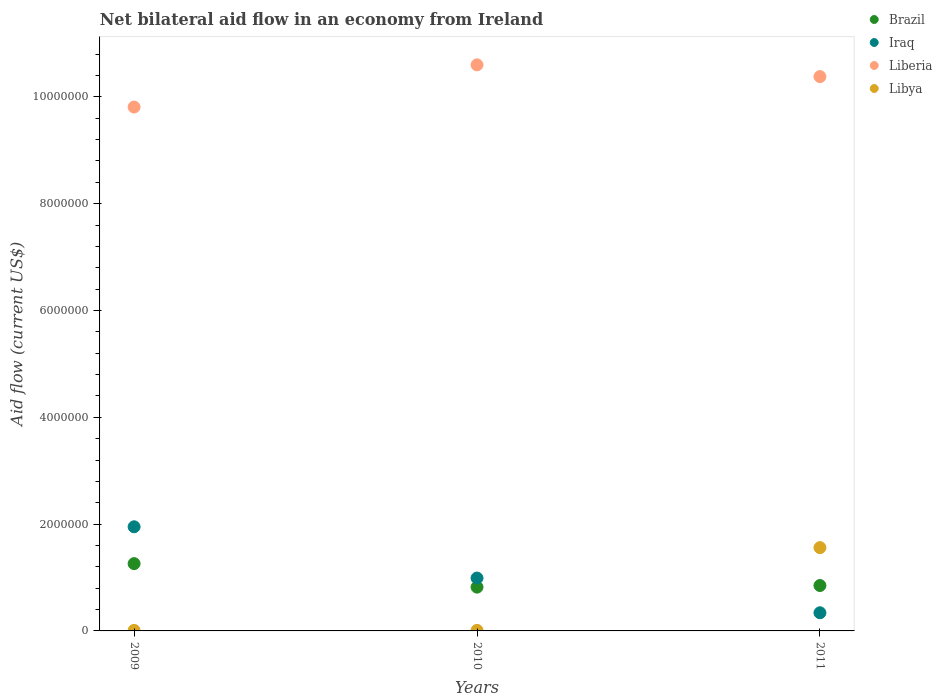How many different coloured dotlines are there?
Offer a very short reply. 4. What is the net bilateral aid flow in Iraq in 2009?
Your answer should be compact. 1.95e+06. Across all years, what is the maximum net bilateral aid flow in Liberia?
Offer a very short reply. 1.06e+07. Across all years, what is the minimum net bilateral aid flow in Brazil?
Your response must be concise. 8.20e+05. In which year was the net bilateral aid flow in Libya maximum?
Ensure brevity in your answer.  2011. In which year was the net bilateral aid flow in Liberia minimum?
Your answer should be compact. 2009. What is the total net bilateral aid flow in Liberia in the graph?
Ensure brevity in your answer.  3.08e+07. What is the difference between the net bilateral aid flow in Brazil in 2009 and that in 2011?
Give a very brief answer. 4.10e+05. What is the difference between the net bilateral aid flow in Liberia in 2011 and the net bilateral aid flow in Iraq in 2010?
Your response must be concise. 9.39e+06. What is the average net bilateral aid flow in Liberia per year?
Your answer should be compact. 1.03e+07. In the year 2010, what is the difference between the net bilateral aid flow in Liberia and net bilateral aid flow in Iraq?
Your answer should be very brief. 9.61e+06. What is the ratio of the net bilateral aid flow in Libya in 2009 to that in 2011?
Make the answer very short. 0.01. Is the net bilateral aid flow in Brazil in 2010 less than that in 2011?
Your answer should be very brief. Yes. What is the difference between the highest and the second highest net bilateral aid flow in Libya?
Ensure brevity in your answer.  1.55e+06. What is the difference between the highest and the lowest net bilateral aid flow in Libya?
Provide a succinct answer. 1.55e+06. In how many years, is the net bilateral aid flow in Iraq greater than the average net bilateral aid flow in Iraq taken over all years?
Offer a very short reply. 1. Is it the case that in every year, the sum of the net bilateral aid flow in Libya and net bilateral aid flow in Brazil  is greater than the sum of net bilateral aid flow in Liberia and net bilateral aid flow in Iraq?
Your answer should be compact. No. Does the net bilateral aid flow in Iraq monotonically increase over the years?
Ensure brevity in your answer.  No. Is the net bilateral aid flow in Libya strictly greater than the net bilateral aid flow in Iraq over the years?
Offer a very short reply. No. How many dotlines are there?
Offer a terse response. 4. How many years are there in the graph?
Make the answer very short. 3. Does the graph contain any zero values?
Give a very brief answer. No. Does the graph contain grids?
Give a very brief answer. No. Where does the legend appear in the graph?
Ensure brevity in your answer.  Top right. How many legend labels are there?
Make the answer very short. 4. What is the title of the graph?
Keep it short and to the point. Net bilateral aid flow in an economy from Ireland. Does "Gabon" appear as one of the legend labels in the graph?
Make the answer very short. No. What is the label or title of the Y-axis?
Your answer should be compact. Aid flow (current US$). What is the Aid flow (current US$) in Brazil in 2009?
Provide a succinct answer. 1.26e+06. What is the Aid flow (current US$) of Iraq in 2009?
Your answer should be compact. 1.95e+06. What is the Aid flow (current US$) in Liberia in 2009?
Provide a succinct answer. 9.81e+06. What is the Aid flow (current US$) of Brazil in 2010?
Your response must be concise. 8.20e+05. What is the Aid flow (current US$) of Iraq in 2010?
Offer a very short reply. 9.90e+05. What is the Aid flow (current US$) of Liberia in 2010?
Make the answer very short. 1.06e+07. What is the Aid flow (current US$) of Brazil in 2011?
Make the answer very short. 8.50e+05. What is the Aid flow (current US$) in Liberia in 2011?
Make the answer very short. 1.04e+07. What is the Aid flow (current US$) of Libya in 2011?
Your answer should be compact. 1.56e+06. Across all years, what is the maximum Aid flow (current US$) in Brazil?
Your answer should be very brief. 1.26e+06. Across all years, what is the maximum Aid flow (current US$) of Iraq?
Your response must be concise. 1.95e+06. Across all years, what is the maximum Aid flow (current US$) in Liberia?
Offer a very short reply. 1.06e+07. Across all years, what is the maximum Aid flow (current US$) of Libya?
Your answer should be very brief. 1.56e+06. Across all years, what is the minimum Aid flow (current US$) of Brazil?
Make the answer very short. 8.20e+05. Across all years, what is the minimum Aid flow (current US$) in Liberia?
Provide a short and direct response. 9.81e+06. What is the total Aid flow (current US$) of Brazil in the graph?
Provide a short and direct response. 2.93e+06. What is the total Aid flow (current US$) of Iraq in the graph?
Your answer should be very brief. 3.28e+06. What is the total Aid flow (current US$) in Liberia in the graph?
Ensure brevity in your answer.  3.08e+07. What is the total Aid flow (current US$) in Libya in the graph?
Offer a terse response. 1.58e+06. What is the difference between the Aid flow (current US$) in Brazil in 2009 and that in 2010?
Offer a terse response. 4.40e+05. What is the difference between the Aid flow (current US$) in Iraq in 2009 and that in 2010?
Your answer should be compact. 9.60e+05. What is the difference between the Aid flow (current US$) in Liberia in 2009 and that in 2010?
Provide a succinct answer. -7.90e+05. What is the difference between the Aid flow (current US$) in Brazil in 2009 and that in 2011?
Your response must be concise. 4.10e+05. What is the difference between the Aid flow (current US$) in Iraq in 2009 and that in 2011?
Keep it short and to the point. 1.61e+06. What is the difference between the Aid flow (current US$) of Liberia in 2009 and that in 2011?
Offer a very short reply. -5.70e+05. What is the difference between the Aid flow (current US$) of Libya in 2009 and that in 2011?
Your response must be concise. -1.55e+06. What is the difference between the Aid flow (current US$) in Brazil in 2010 and that in 2011?
Offer a terse response. -3.00e+04. What is the difference between the Aid flow (current US$) of Iraq in 2010 and that in 2011?
Keep it short and to the point. 6.50e+05. What is the difference between the Aid flow (current US$) of Liberia in 2010 and that in 2011?
Offer a terse response. 2.20e+05. What is the difference between the Aid flow (current US$) in Libya in 2010 and that in 2011?
Your answer should be very brief. -1.55e+06. What is the difference between the Aid flow (current US$) of Brazil in 2009 and the Aid flow (current US$) of Liberia in 2010?
Your response must be concise. -9.34e+06. What is the difference between the Aid flow (current US$) in Brazil in 2009 and the Aid flow (current US$) in Libya in 2010?
Provide a short and direct response. 1.25e+06. What is the difference between the Aid flow (current US$) of Iraq in 2009 and the Aid flow (current US$) of Liberia in 2010?
Offer a very short reply. -8.65e+06. What is the difference between the Aid flow (current US$) in Iraq in 2009 and the Aid flow (current US$) in Libya in 2010?
Your answer should be very brief. 1.94e+06. What is the difference between the Aid flow (current US$) of Liberia in 2009 and the Aid flow (current US$) of Libya in 2010?
Make the answer very short. 9.80e+06. What is the difference between the Aid flow (current US$) in Brazil in 2009 and the Aid flow (current US$) in Iraq in 2011?
Keep it short and to the point. 9.20e+05. What is the difference between the Aid flow (current US$) of Brazil in 2009 and the Aid flow (current US$) of Liberia in 2011?
Your answer should be very brief. -9.12e+06. What is the difference between the Aid flow (current US$) of Iraq in 2009 and the Aid flow (current US$) of Liberia in 2011?
Make the answer very short. -8.43e+06. What is the difference between the Aid flow (current US$) of Iraq in 2009 and the Aid flow (current US$) of Libya in 2011?
Offer a very short reply. 3.90e+05. What is the difference between the Aid flow (current US$) of Liberia in 2009 and the Aid flow (current US$) of Libya in 2011?
Your answer should be very brief. 8.25e+06. What is the difference between the Aid flow (current US$) in Brazil in 2010 and the Aid flow (current US$) in Liberia in 2011?
Offer a terse response. -9.56e+06. What is the difference between the Aid flow (current US$) of Brazil in 2010 and the Aid flow (current US$) of Libya in 2011?
Provide a succinct answer. -7.40e+05. What is the difference between the Aid flow (current US$) in Iraq in 2010 and the Aid flow (current US$) in Liberia in 2011?
Keep it short and to the point. -9.39e+06. What is the difference between the Aid flow (current US$) of Iraq in 2010 and the Aid flow (current US$) of Libya in 2011?
Give a very brief answer. -5.70e+05. What is the difference between the Aid flow (current US$) in Liberia in 2010 and the Aid flow (current US$) in Libya in 2011?
Offer a very short reply. 9.04e+06. What is the average Aid flow (current US$) of Brazil per year?
Offer a very short reply. 9.77e+05. What is the average Aid flow (current US$) of Iraq per year?
Offer a terse response. 1.09e+06. What is the average Aid flow (current US$) in Liberia per year?
Your answer should be compact. 1.03e+07. What is the average Aid flow (current US$) of Libya per year?
Make the answer very short. 5.27e+05. In the year 2009, what is the difference between the Aid flow (current US$) in Brazil and Aid flow (current US$) in Iraq?
Keep it short and to the point. -6.90e+05. In the year 2009, what is the difference between the Aid flow (current US$) in Brazil and Aid flow (current US$) in Liberia?
Ensure brevity in your answer.  -8.55e+06. In the year 2009, what is the difference between the Aid flow (current US$) in Brazil and Aid flow (current US$) in Libya?
Give a very brief answer. 1.25e+06. In the year 2009, what is the difference between the Aid flow (current US$) in Iraq and Aid flow (current US$) in Liberia?
Keep it short and to the point. -7.86e+06. In the year 2009, what is the difference between the Aid flow (current US$) of Iraq and Aid flow (current US$) of Libya?
Give a very brief answer. 1.94e+06. In the year 2009, what is the difference between the Aid flow (current US$) in Liberia and Aid flow (current US$) in Libya?
Offer a terse response. 9.80e+06. In the year 2010, what is the difference between the Aid flow (current US$) in Brazil and Aid flow (current US$) in Iraq?
Keep it short and to the point. -1.70e+05. In the year 2010, what is the difference between the Aid flow (current US$) in Brazil and Aid flow (current US$) in Liberia?
Offer a very short reply. -9.78e+06. In the year 2010, what is the difference between the Aid flow (current US$) in Brazil and Aid flow (current US$) in Libya?
Ensure brevity in your answer.  8.10e+05. In the year 2010, what is the difference between the Aid flow (current US$) in Iraq and Aid flow (current US$) in Liberia?
Give a very brief answer. -9.61e+06. In the year 2010, what is the difference between the Aid flow (current US$) in Iraq and Aid flow (current US$) in Libya?
Keep it short and to the point. 9.80e+05. In the year 2010, what is the difference between the Aid flow (current US$) in Liberia and Aid flow (current US$) in Libya?
Provide a short and direct response. 1.06e+07. In the year 2011, what is the difference between the Aid flow (current US$) of Brazil and Aid flow (current US$) of Iraq?
Your response must be concise. 5.10e+05. In the year 2011, what is the difference between the Aid flow (current US$) in Brazil and Aid flow (current US$) in Liberia?
Provide a succinct answer. -9.53e+06. In the year 2011, what is the difference between the Aid flow (current US$) in Brazil and Aid flow (current US$) in Libya?
Offer a very short reply. -7.10e+05. In the year 2011, what is the difference between the Aid flow (current US$) in Iraq and Aid flow (current US$) in Liberia?
Your answer should be very brief. -1.00e+07. In the year 2011, what is the difference between the Aid flow (current US$) in Iraq and Aid flow (current US$) in Libya?
Offer a very short reply. -1.22e+06. In the year 2011, what is the difference between the Aid flow (current US$) in Liberia and Aid flow (current US$) in Libya?
Keep it short and to the point. 8.82e+06. What is the ratio of the Aid flow (current US$) in Brazil in 2009 to that in 2010?
Offer a terse response. 1.54. What is the ratio of the Aid flow (current US$) in Iraq in 2009 to that in 2010?
Keep it short and to the point. 1.97. What is the ratio of the Aid flow (current US$) in Liberia in 2009 to that in 2010?
Your answer should be compact. 0.93. What is the ratio of the Aid flow (current US$) of Brazil in 2009 to that in 2011?
Provide a short and direct response. 1.48. What is the ratio of the Aid flow (current US$) of Iraq in 2009 to that in 2011?
Provide a succinct answer. 5.74. What is the ratio of the Aid flow (current US$) of Liberia in 2009 to that in 2011?
Keep it short and to the point. 0.95. What is the ratio of the Aid flow (current US$) in Libya in 2009 to that in 2011?
Provide a succinct answer. 0.01. What is the ratio of the Aid flow (current US$) of Brazil in 2010 to that in 2011?
Keep it short and to the point. 0.96. What is the ratio of the Aid flow (current US$) in Iraq in 2010 to that in 2011?
Your response must be concise. 2.91. What is the ratio of the Aid flow (current US$) in Liberia in 2010 to that in 2011?
Ensure brevity in your answer.  1.02. What is the ratio of the Aid flow (current US$) in Libya in 2010 to that in 2011?
Offer a terse response. 0.01. What is the difference between the highest and the second highest Aid flow (current US$) in Iraq?
Give a very brief answer. 9.60e+05. What is the difference between the highest and the second highest Aid flow (current US$) of Libya?
Provide a succinct answer. 1.55e+06. What is the difference between the highest and the lowest Aid flow (current US$) in Iraq?
Offer a very short reply. 1.61e+06. What is the difference between the highest and the lowest Aid flow (current US$) in Liberia?
Make the answer very short. 7.90e+05. What is the difference between the highest and the lowest Aid flow (current US$) in Libya?
Your answer should be very brief. 1.55e+06. 